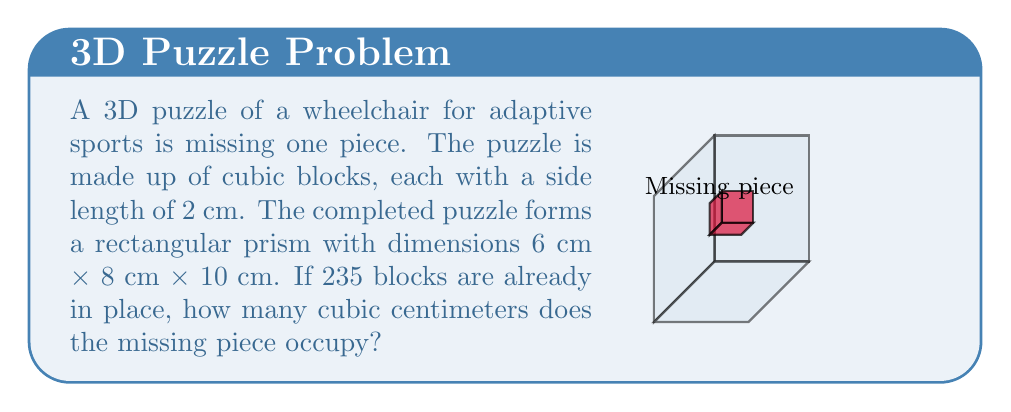Solve this math problem. Let's approach this step-by-step:

1) First, we need to calculate the total volume of the completed puzzle:
   $$ V_{total} = 6 \text{ cm} \times 8 \text{ cm} \times 10 \text{ cm} = 480 \text{ cm}^3 $$

2) Now, we need to find the volume of each cubic block:
   $$ V_{block} = 2 \text{ cm} \times 2 \text{ cm} \times 2 \text{ cm} = 8 \text{ cm}^3 $$

3) We can calculate the total number of blocks in the completed puzzle:
   $$ N_{total} = \frac{V_{total}}{V_{block}} = \frac{480 \text{ cm}^3}{8 \text{ cm}^3} = 60 \text{ blocks} $$

4) We know that 235 blocks are already in place, so the number of missing blocks is:
   $$ N_{missing} = 60 - 235 = 1 \text{ block} $$

5) Therefore, the volume of the missing piece is:
   $$ V_{missing} = N_{missing} \times V_{block} = 1 \times 8 \text{ cm}^3 = 8 \text{ cm}^3 $$

Thus, the missing piece occupies 8 cubic centimeters.
Answer: 8 cm³ 